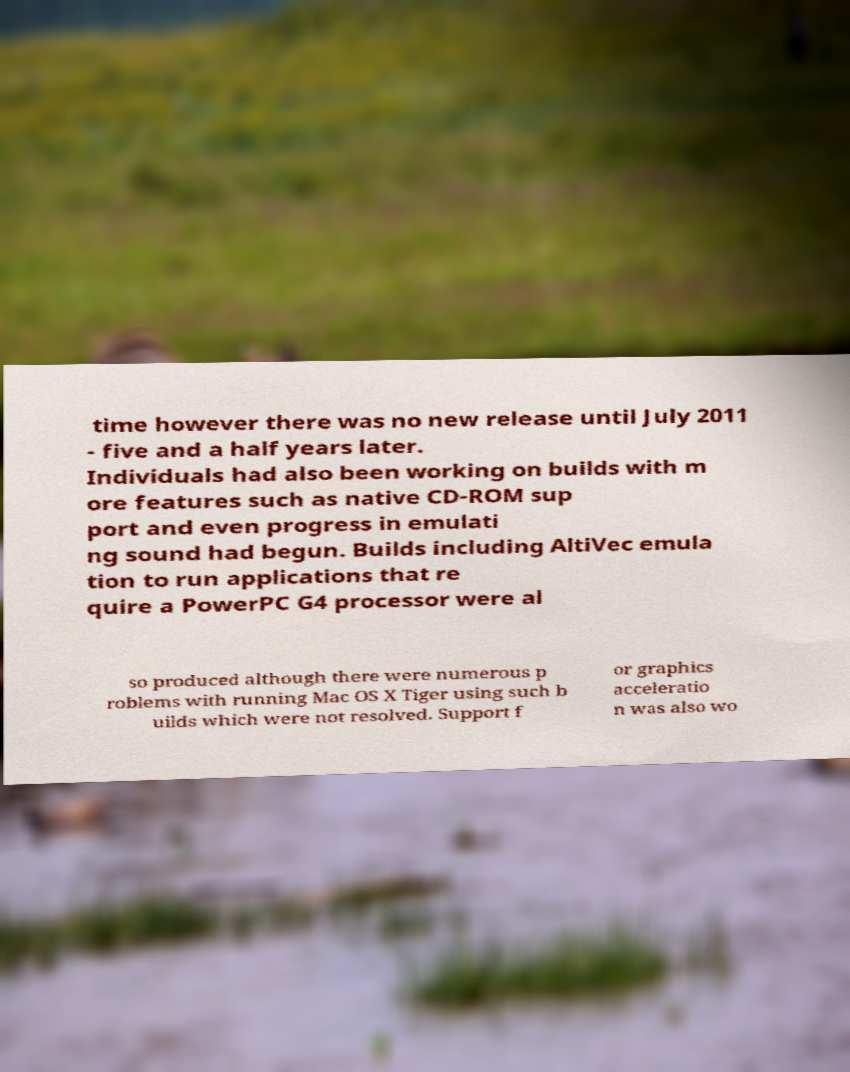Could you assist in decoding the text presented in this image and type it out clearly? time however there was no new release until July 2011 - five and a half years later. Individuals had also been working on builds with m ore features such as native CD-ROM sup port and even progress in emulati ng sound had begun. Builds including AltiVec emula tion to run applications that re quire a PowerPC G4 processor were al so produced although there were numerous p roblems with running Mac OS X Tiger using such b uilds which were not resolved. Support f or graphics acceleratio n was also wo 